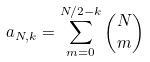Convert formula to latex. <formula><loc_0><loc_0><loc_500><loc_500>a _ { N , k } = \sum _ { m = 0 } ^ { N / 2 - k } { N \choose m }</formula> 